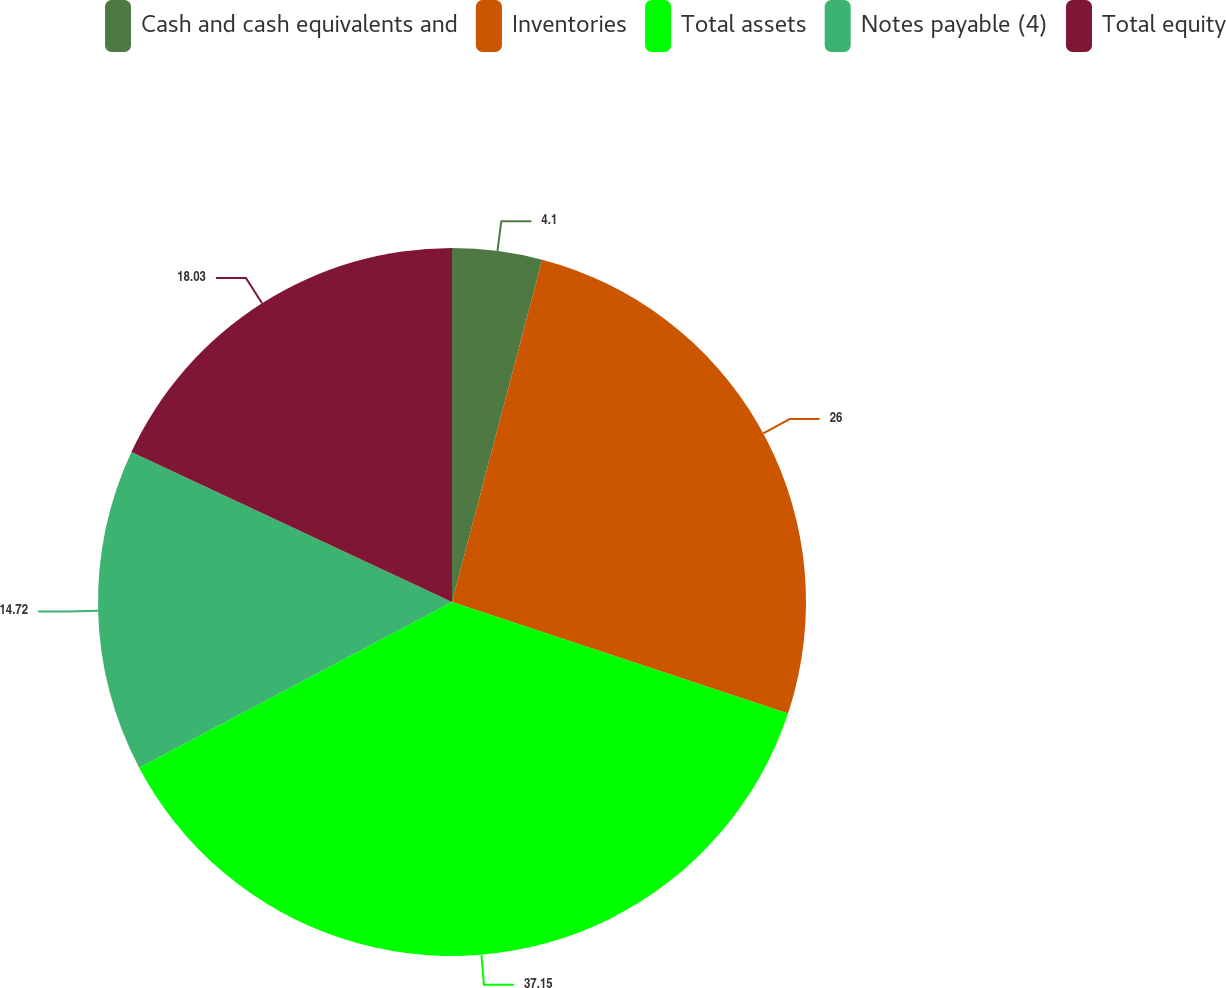Convert chart. <chart><loc_0><loc_0><loc_500><loc_500><pie_chart><fcel>Cash and cash equivalents and<fcel>Inventories<fcel>Total assets<fcel>Notes payable (4)<fcel>Total equity<nl><fcel>4.1%<fcel>26.0%<fcel>37.15%<fcel>14.72%<fcel>18.03%<nl></chart> 